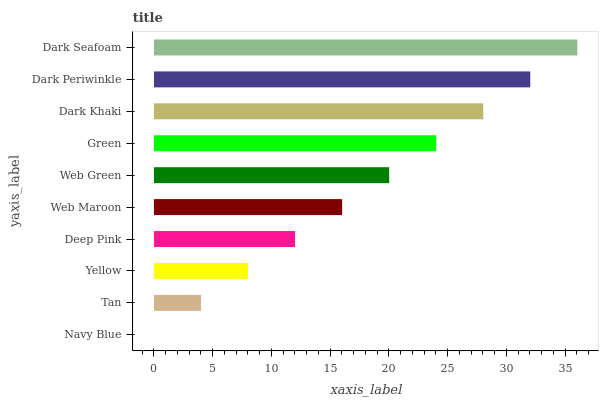Is Navy Blue the minimum?
Answer yes or no. Yes. Is Dark Seafoam the maximum?
Answer yes or no. Yes. Is Tan the minimum?
Answer yes or no. No. Is Tan the maximum?
Answer yes or no. No. Is Tan greater than Navy Blue?
Answer yes or no. Yes. Is Navy Blue less than Tan?
Answer yes or no. Yes. Is Navy Blue greater than Tan?
Answer yes or no. No. Is Tan less than Navy Blue?
Answer yes or no. No. Is Web Green the high median?
Answer yes or no. Yes. Is Web Maroon the low median?
Answer yes or no. Yes. Is Dark Khaki the high median?
Answer yes or no. No. Is Deep Pink the low median?
Answer yes or no. No. 